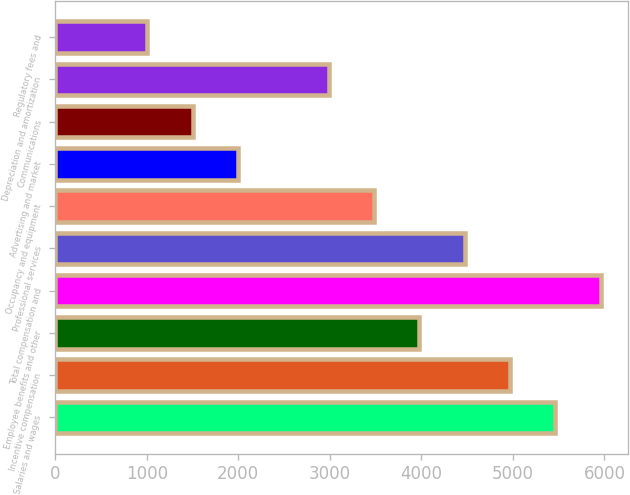Convert chart. <chart><loc_0><loc_0><loc_500><loc_500><bar_chart><fcel>Salaries and wages<fcel>Incentive compensation<fcel>Employee benefits and other<fcel>Total compensation and<fcel>Professional services<fcel>Occupancy and equipment<fcel>Advertising and market<fcel>Communications<fcel>Depreciation and amortization<fcel>Regulatory fees and<nl><fcel>5463.11<fcel>4968<fcel>3977.78<fcel>5958.22<fcel>4472.89<fcel>3482.67<fcel>1997.34<fcel>1502.23<fcel>2987.56<fcel>1007.12<nl></chart> 